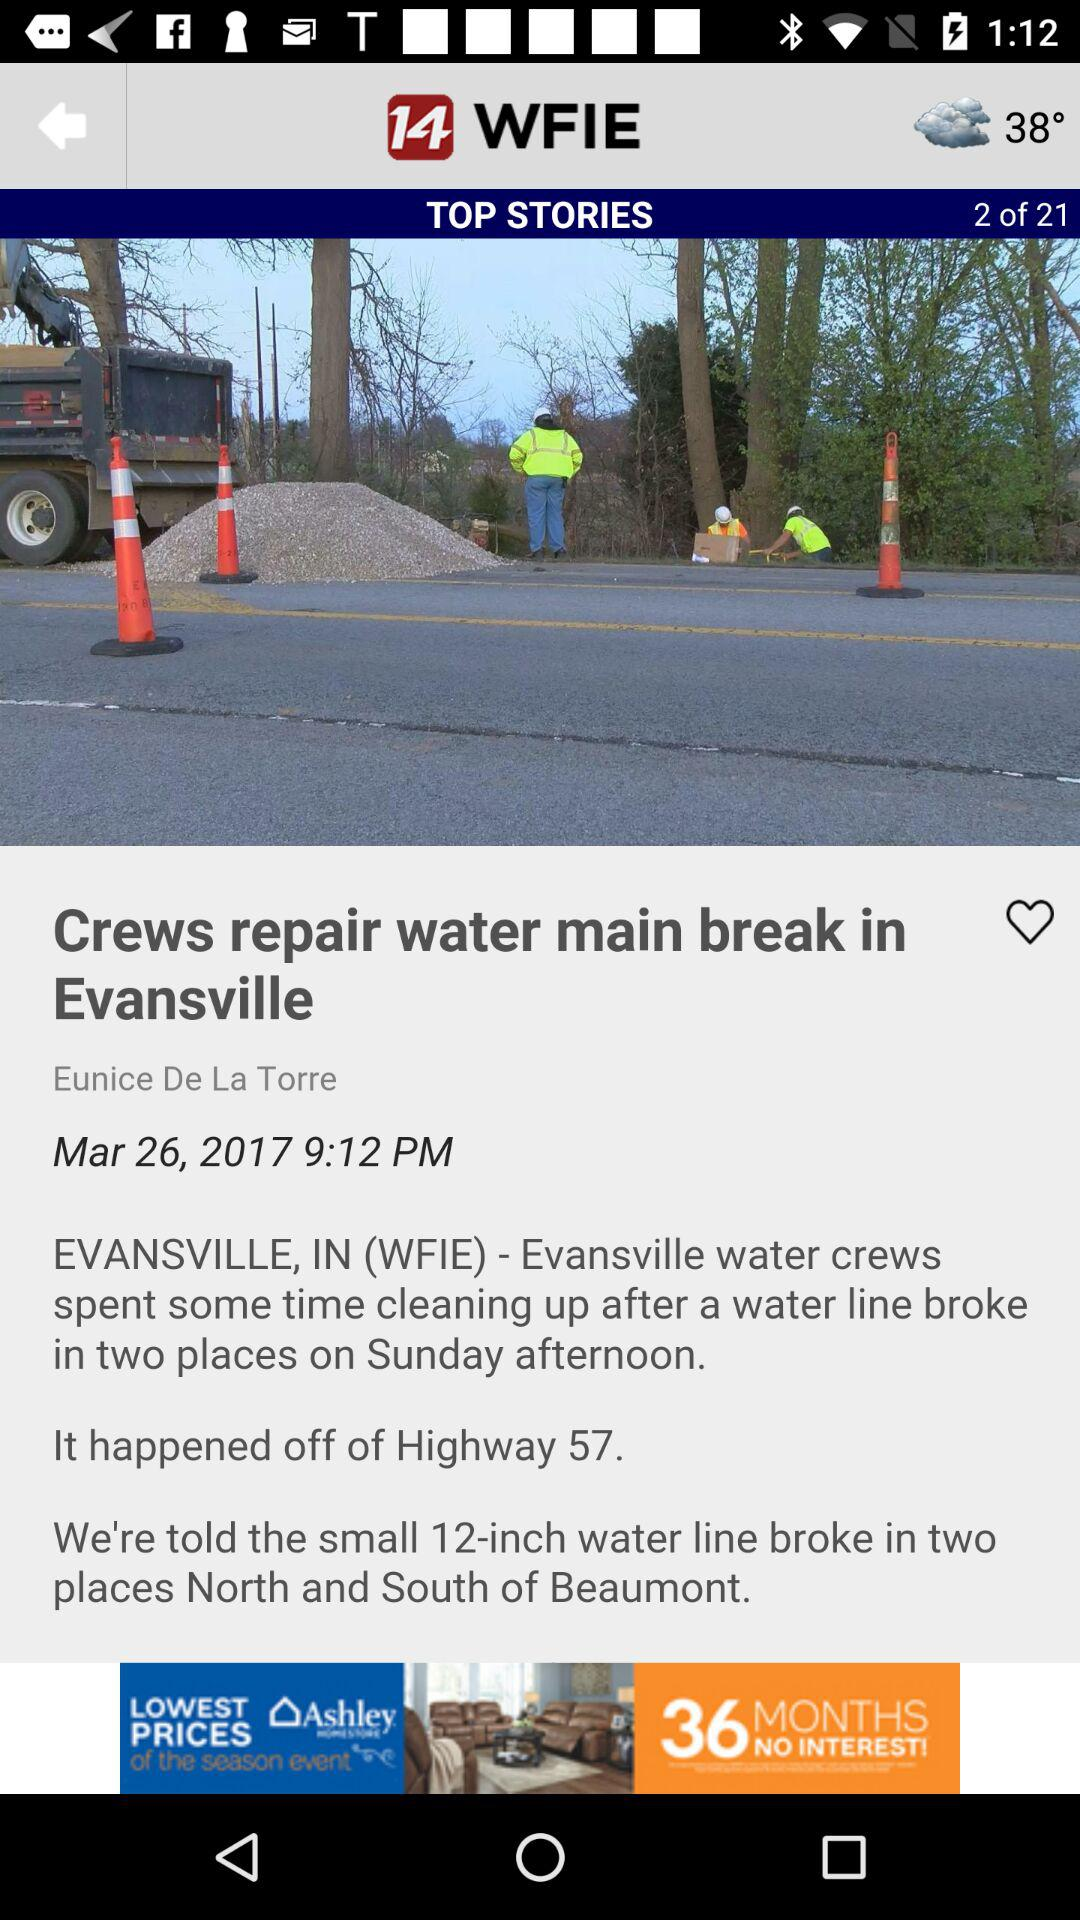What is the total number of stories? The total number of stories is 21. 